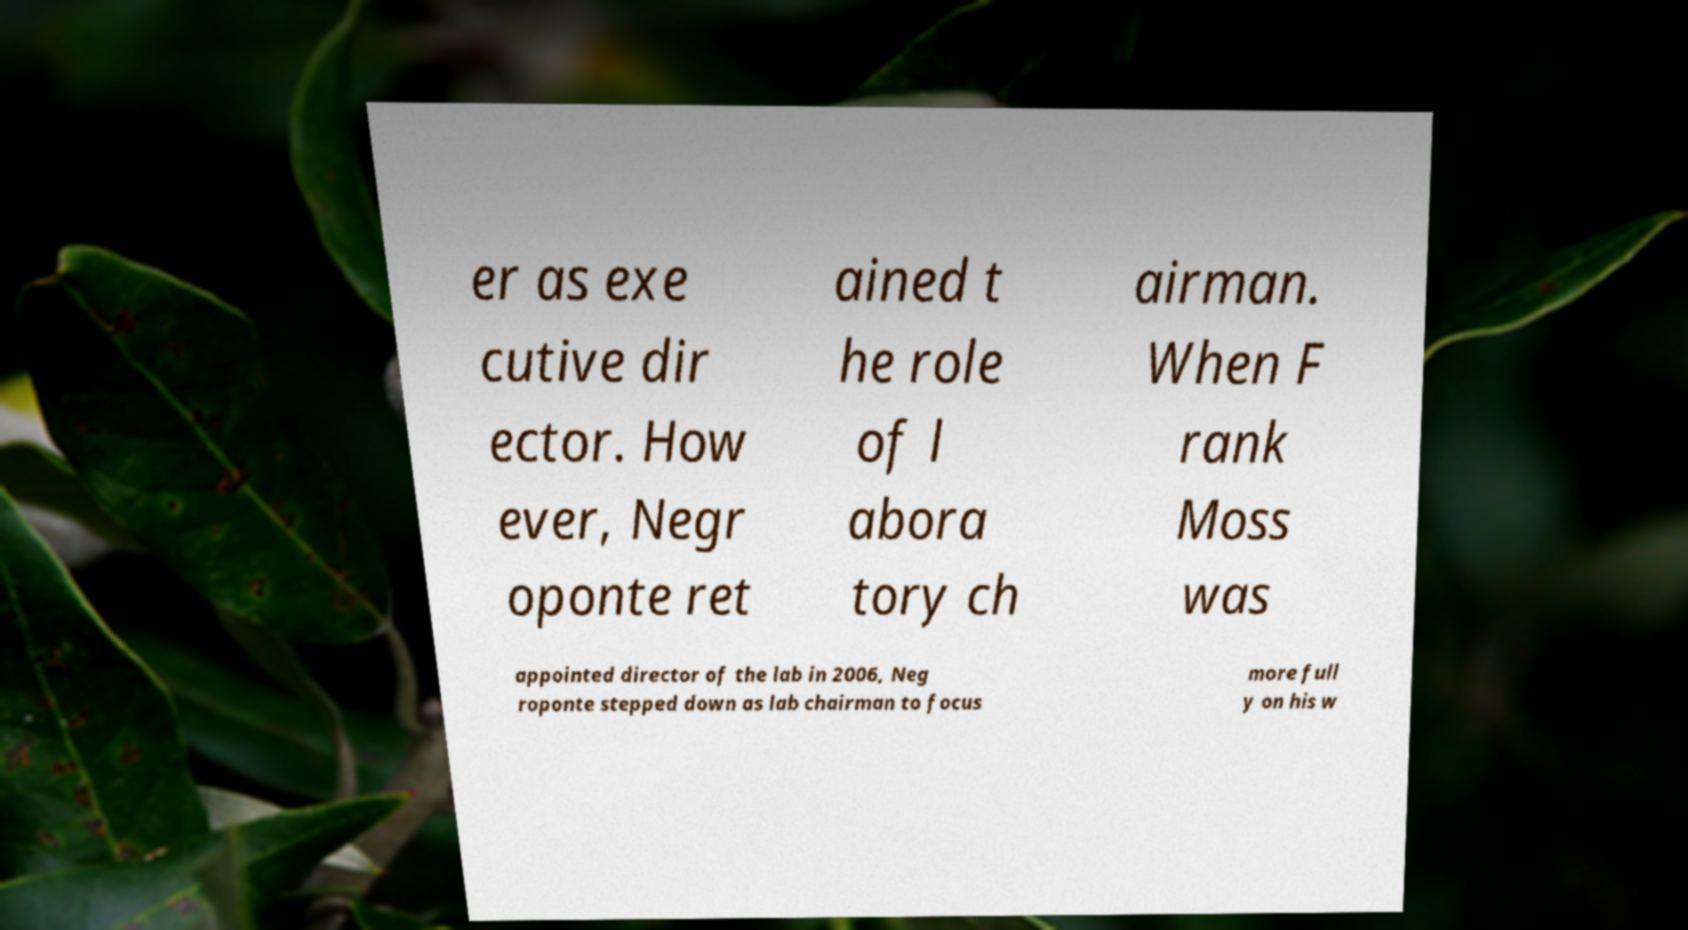I need the written content from this picture converted into text. Can you do that? er as exe cutive dir ector. How ever, Negr oponte ret ained t he role of l abora tory ch airman. When F rank Moss was appointed director of the lab in 2006, Neg roponte stepped down as lab chairman to focus more full y on his w 